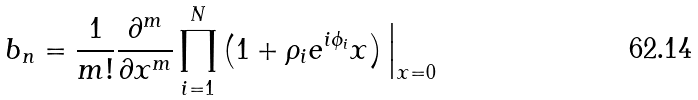<formula> <loc_0><loc_0><loc_500><loc_500>b _ { n } = \frac { 1 } { m ! } \frac { \partial ^ { m } } { \partial x ^ { m } } \prod _ { i = 1 } ^ { N } \left ( 1 + \rho _ { i } e ^ { i \phi _ { i } } x \right ) \Big | _ { x = 0 }</formula> 